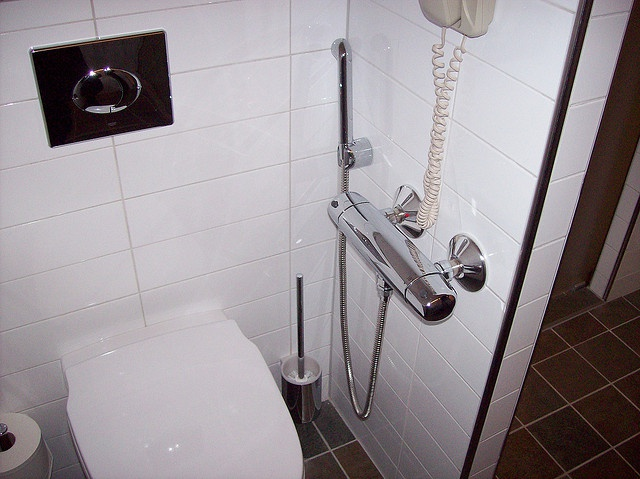Describe the objects in this image and their specific colors. I can see a toilet in black, darkgray, and lightgray tones in this image. 